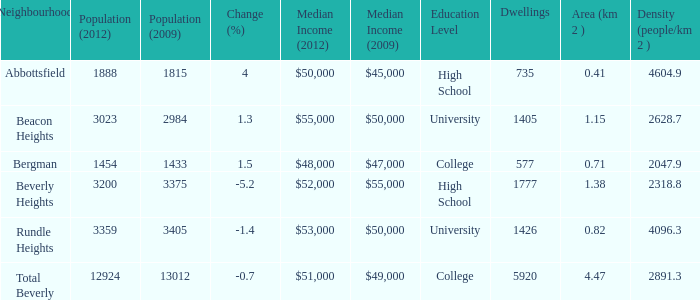How many Dwellings does Beverly Heights have that have a change percent larger than -5.2? None. 